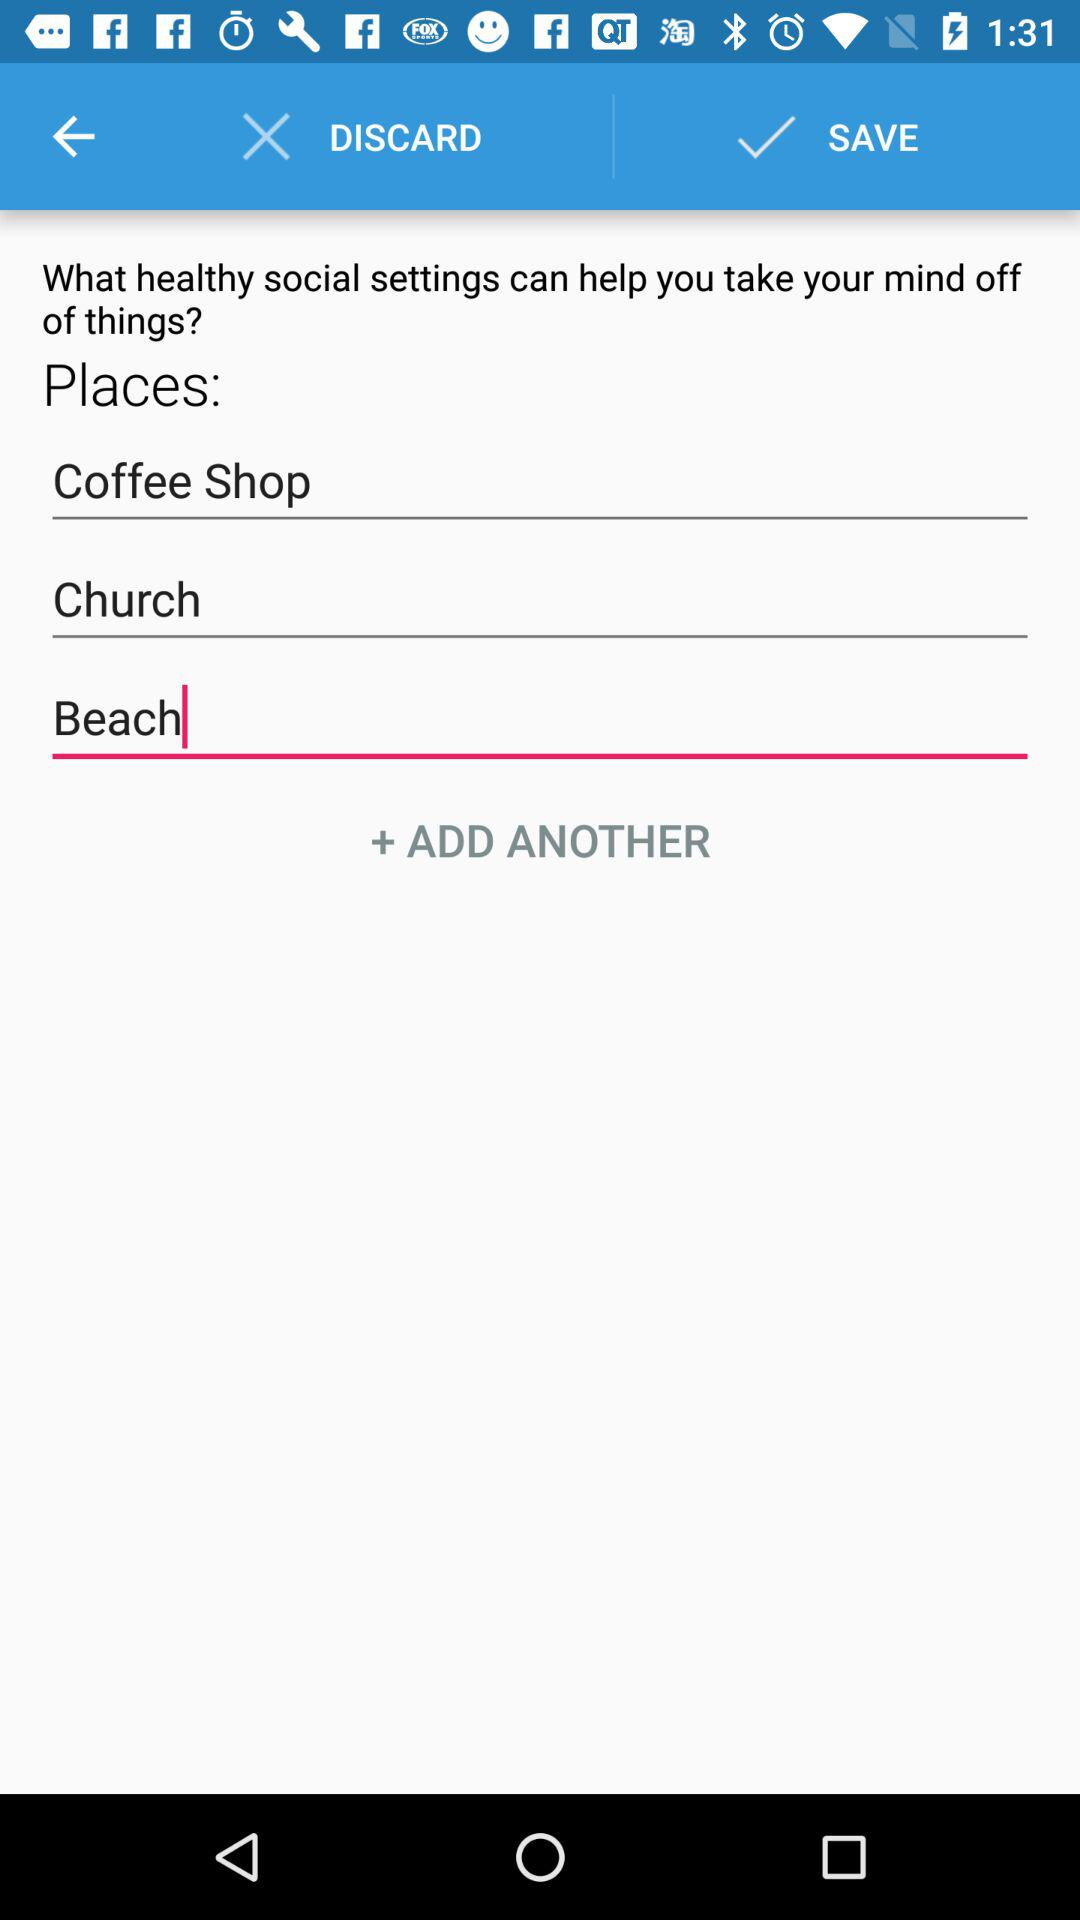Which places are entered? The entered places are Coffee Shop, Church and Beach. 